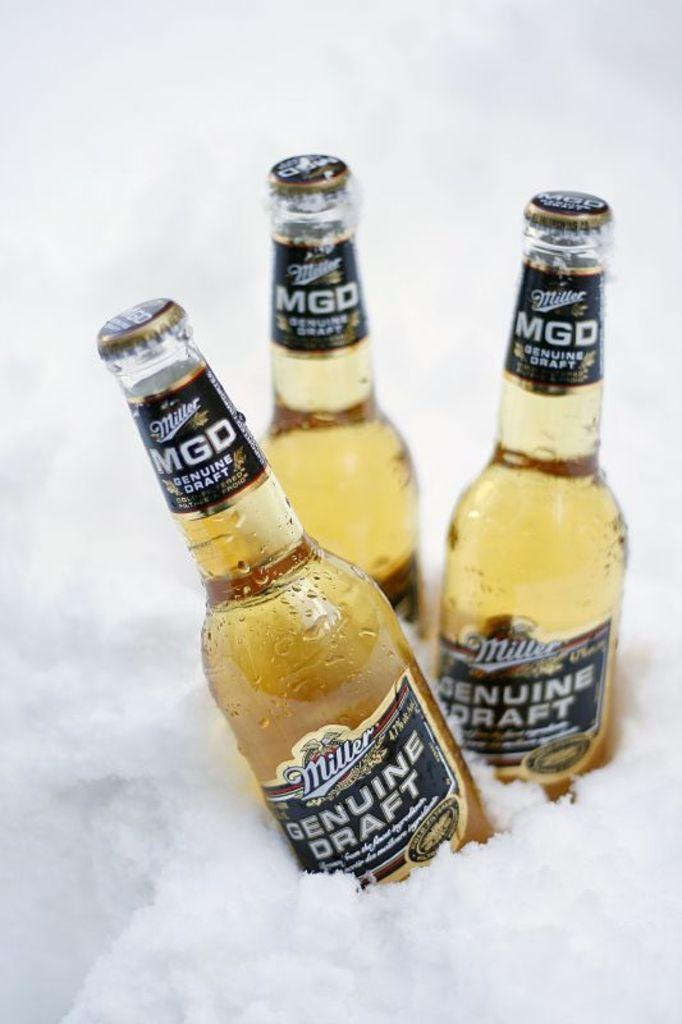Provide a one-sentence caption for the provided image. Three bottles of Miller Genuine draft in ice. 